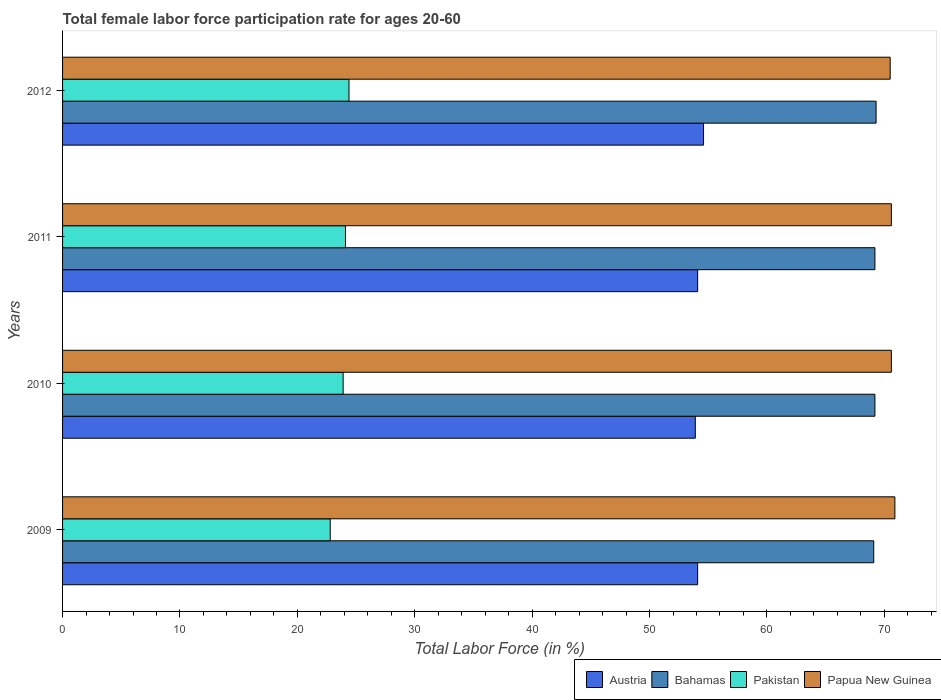How many different coloured bars are there?
Make the answer very short. 4. Are the number of bars on each tick of the Y-axis equal?
Keep it short and to the point. Yes. How many bars are there on the 4th tick from the top?
Make the answer very short. 4. In how many cases, is the number of bars for a given year not equal to the number of legend labels?
Keep it short and to the point. 0. What is the female labor force participation rate in Papua New Guinea in 2011?
Offer a terse response. 70.6. Across all years, what is the maximum female labor force participation rate in Austria?
Provide a short and direct response. 54.6. Across all years, what is the minimum female labor force participation rate in Austria?
Keep it short and to the point. 53.9. In which year was the female labor force participation rate in Austria minimum?
Your answer should be compact. 2010. What is the total female labor force participation rate in Austria in the graph?
Your response must be concise. 216.7. What is the difference between the female labor force participation rate in Austria in 2010 and that in 2012?
Offer a very short reply. -0.7. What is the difference between the female labor force participation rate in Bahamas in 2009 and the female labor force participation rate in Austria in 2011?
Make the answer very short. 15. What is the average female labor force participation rate in Pakistan per year?
Make the answer very short. 23.8. In the year 2009, what is the difference between the female labor force participation rate in Pakistan and female labor force participation rate in Bahamas?
Your answer should be compact. -46.3. What is the ratio of the female labor force participation rate in Papua New Guinea in 2009 to that in 2011?
Offer a terse response. 1. Is the female labor force participation rate in Bahamas in 2011 less than that in 2012?
Your response must be concise. Yes. What is the difference between the highest and the second highest female labor force participation rate in Papua New Guinea?
Make the answer very short. 0.3. What is the difference between the highest and the lowest female labor force participation rate in Papua New Guinea?
Your response must be concise. 0.4. In how many years, is the female labor force participation rate in Papua New Guinea greater than the average female labor force participation rate in Papua New Guinea taken over all years?
Provide a short and direct response. 1. Is the sum of the female labor force participation rate in Austria in 2009 and 2010 greater than the maximum female labor force participation rate in Pakistan across all years?
Provide a short and direct response. Yes. What does the 4th bar from the top in 2012 represents?
Your response must be concise. Austria. How many bars are there?
Your answer should be compact. 16. How many years are there in the graph?
Provide a short and direct response. 4. What is the difference between two consecutive major ticks on the X-axis?
Your answer should be compact. 10. Are the values on the major ticks of X-axis written in scientific E-notation?
Your answer should be compact. No. Where does the legend appear in the graph?
Offer a very short reply. Bottom right. What is the title of the graph?
Your answer should be compact. Total female labor force participation rate for ages 20-60. Does "Gambia, The" appear as one of the legend labels in the graph?
Offer a terse response. No. What is the Total Labor Force (in %) in Austria in 2009?
Your answer should be very brief. 54.1. What is the Total Labor Force (in %) in Bahamas in 2009?
Your answer should be very brief. 69.1. What is the Total Labor Force (in %) of Pakistan in 2009?
Give a very brief answer. 22.8. What is the Total Labor Force (in %) in Papua New Guinea in 2009?
Make the answer very short. 70.9. What is the Total Labor Force (in %) in Austria in 2010?
Offer a very short reply. 53.9. What is the Total Labor Force (in %) of Bahamas in 2010?
Offer a very short reply. 69.2. What is the Total Labor Force (in %) in Pakistan in 2010?
Your response must be concise. 23.9. What is the Total Labor Force (in %) in Papua New Guinea in 2010?
Make the answer very short. 70.6. What is the Total Labor Force (in %) of Austria in 2011?
Your answer should be compact. 54.1. What is the Total Labor Force (in %) in Bahamas in 2011?
Your answer should be very brief. 69.2. What is the Total Labor Force (in %) in Pakistan in 2011?
Provide a short and direct response. 24.1. What is the Total Labor Force (in %) of Papua New Guinea in 2011?
Keep it short and to the point. 70.6. What is the Total Labor Force (in %) of Austria in 2012?
Ensure brevity in your answer.  54.6. What is the Total Labor Force (in %) of Bahamas in 2012?
Your response must be concise. 69.3. What is the Total Labor Force (in %) of Pakistan in 2012?
Provide a short and direct response. 24.4. What is the Total Labor Force (in %) of Papua New Guinea in 2012?
Provide a short and direct response. 70.5. Across all years, what is the maximum Total Labor Force (in %) in Austria?
Ensure brevity in your answer.  54.6. Across all years, what is the maximum Total Labor Force (in %) in Bahamas?
Keep it short and to the point. 69.3. Across all years, what is the maximum Total Labor Force (in %) of Pakistan?
Your response must be concise. 24.4. Across all years, what is the maximum Total Labor Force (in %) in Papua New Guinea?
Make the answer very short. 70.9. Across all years, what is the minimum Total Labor Force (in %) of Austria?
Make the answer very short. 53.9. Across all years, what is the minimum Total Labor Force (in %) in Bahamas?
Provide a succinct answer. 69.1. Across all years, what is the minimum Total Labor Force (in %) in Pakistan?
Ensure brevity in your answer.  22.8. Across all years, what is the minimum Total Labor Force (in %) of Papua New Guinea?
Your answer should be very brief. 70.5. What is the total Total Labor Force (in %) of Austria in the graph?
Offer a terse response. 216.7. What is the total Total Labor Force (in %) of Bahamas in the graph?
Offer a terse response. 276.8. What is the total Total Labor Force (in %) of Pakistan in the graph?
Ensure brevity in your answer.  95.2. What is the total Total Labor Force (in %) in Papua New Guinea in the graph?
Your response must be concise. 282.6. What is the difference between the Total Labor Force (in %) in Papua New Guinea in 2009 and that in 2010?
Provide a succinct answer. 0.3. What is the difference between the Total Labor Force (in %) of Austria in 2009 and that in 2011?
Offer a terse response. 0. What is the difference between the Total Labor Force (in %) of Pakistan in 2009 and that in 2011?
Make the answer very short. -1.3. What is the difference between the Total Labor Force (in %) of Papua New Guinea in 2009 and that in 2011?
Keep it short and to the point. 0.3. What is the difference between the Total Labor Force (in %) of Papua New Guinea in 2009 and that in 2012?
Ensure brevity in your answer.  0.4. What is the difference between the Total Labor Force (in %) of Austria in 2010 and that in 2011?
Provide a succinct answer. -0.2. What is the difference between the Total Labor Force (in %) of Bahamas in 2010 and that in 2011?
Give a very brief answer. 0. What is the difference between the Total Labor Force (in %) of Austria in 2010 and that in 2012?
Provide a short and direct response. -0.7. What is the difference between the Total Labor Force (in %) of Bahamas in 2010 and that in 2012?
Your response must be concise. -0.1. What is the difference between the Total Labor Force (in %) of Austria in 2011 and that in 2012?
Your response must be concise. -0.5. What is the difference between the Total Labor Force (in %) of Bahamas in 2011 and that in 2012?
Your answer should be very brief. -0.1. What is the difference between the Total Labor Force (in %) of Pakistan in 2011 and that in 2012?
Provide a short and direct response. -0.3. What is the difference between the Total Labor Force (in %) of Papua New Guinea in 2011 and that in 2012?
Your answer should be compact. 0.1. What is the difference between the Total Labor Force (in %) of Austria in 2009 and the Total Labor Force (in %) of Bahamas in 2010?
Keep it short and to the point. -15.1. What is the difference between the Total Labor Force (in %) of Austria in 2009 and the Total Labor Force (in %) of Pakistan in 2010?
Make the answer very short. 30.2. What is the difference between the Total Labor Force (in %) of Austria in 2009 and the Total Labor Force (in %) of Papua New Guinea in 2010?
Your response must be concise. -16.5. What is the difference between the Total Labor Force (in %) in Bahamas in 2009 and the Total Labor Force (in %) in Pakistan in 2010?
Give a very brief answer. 45.2. What is the difference between the Total Labor Force (in %) in Bahamas in 2009 and the Total Labor Force (in %) in Papua New Guinea in 2010?
Provide a short and direct response. -1.5. What is the difference between the Total Labor Force (in %) of Pakistan in 2009 and the Total Labor Force (in %) of Papua New Guinea in 2010?
Your answer should be compact. -47.8. What is the difference between the Total Labor Force (in %) in Austria in 2009 and the Total Labor Force (in %) in Bahamas in 2011?
Provide a short and direct response. -15.1. What is the difference between the Total Labor Force (in %) of Austria in 2009 and the Total Labor Force (in %) of Papua New Guinea in 2011?
Provide a short and direct response. -16.5. What is the difference between the Total Labor Force (in %) in Bahamas in 2009 and the Total Labor Force (in %) in Papua New Guinea in 2011?
Give a very brief answer. -1.5. What is the difference between the Total Labor Force (in %) in Pakistan in 2009 and the Total Labor Force (in %) in Papua New Guinea in 2011?
Your answer should be very brief. -47.8. What is the difference between the Total Labor Force (in %) of Austria in 2009 and the Total Labor Force (in %) of Bahamas in 2012?
Your answer should be very brief. -15.2. What is the difference between the Total Labor Force (in %) of Austria in 2009 and the Total Labor Force (in %) of Pakistan in 2012?
Make the answer very short. 29.7. What is the difference between the Total Labor Force (in %) in Austria in 2009 and the Total Labor Force (in %) in Papua New Guinea in 2012?
Provide a succinct answer. -16.4. What is the difference between the Total Labor Force (in %) in Bahamas in 2009 and the Total Labor Force (in %) in Pakistan in 2012?
Give a very brief answer. 44.7. What is the difference between the Total Labor Force (in %) of Bahamas in 2009 and the Total Labor Force (in %) of Papua New Guinea in 2012?
Offer a very short reply. -1.4. What is the difference between the Total Labor Force (in %) in Pakistan in 2009 and the Total Labor Force (in %) in Papua New Guinea in 2012?
Ensure brevity in your answer.  -47.7. What is the difference between the Total Labor Force (in %) of Austria in 2010 and the Total Labor Force (in %) of Bahamas in 2011?
Provide a short and direct response. -15.3. What is the difference between the Total Labor Force (in %) in Austria in 2010 and the Total Labor Force (in %) in Pakistan in 2011?
Make the answer very short. 29.8. What is the difference between the Total Labor Force (in %) of Austria in 2010 and the Total Labor Force (in %) of Papua New Guinea in 2011?
Provide a succinct answer. -16.7. What is the difference between the Total Labor Force (in %) of Bahamas in 2010 and the Total Labor Force (in %) of Pakistan in 2011?
Your answer should be very brief. 45.1. What is the difference between the Total Labor Force (in %) of Bahamas in 2010 and the Total Labor Force (in %) of Papua New Guinea in 2011?
Your answer should be compact. -1.4. What is the difference between the Total Labor Force (in %) of Pakistan in 2010 and the Total Labor Force (in %) of Papua New Guinea in 2011?
Make the answer very short. -46.7. What is the difference between the Total Labor Force (in %) of Austria in 2010 and the Total Labor Force (in %) of Bahamas in 2012?
Your response must be concise. -15.4. What is the difference between the Total Labor Force (in %) of Austria in 2010 and the Total Labor Force (in %) of Pakistan in 2012?
Ensure brevity in your answer.  29.5. What is the difference between the Total Labor Force (in %) in Austria in 2010 and the Total Labor Force (in %) in Papua New Guinea in 2012?
Give a very brief answer. -16.6. What is the difference between the Total Labor Force (in %) of Bahamas in 2010 and the Total Labor Force (in %) of Pakistan in 2012?
Your response must be concise. 44.8. What is the difference between the Total Labor Force (in %) in Pakistan in 2010 and the Total Labor Force (in %) in Papua New Guinea in 2012?
Offer a very short reply. -46.6. What is the difference between the Total Labor Force (in %) in Austria in 2011 and the Total Labor Force (in %) in Bahamas in 2012?
Ensure brevity in your answer.  -15.2. What is the difference between the Total Labor Force (in %) of Austria in 2011 and the Total Labor Force (in %) of Pakistan in 2012?
Give a very brief answer. 29.7. What is the difference between the Total Labor Force (in %) in Austria in 2011 and the Total Labor Force (in %) in Papua New Guinea in 2012?
Make the answer very short. -16.4. What is the difference between the Total Labor Force (in %) in Bahamas in 2011 and the Total Labor Force (in %) in Pakistan in 2012?
Ensure brevity in your answer.  44.8. What is the difference between the Total Labor Force (in %) of Pakistan in 2011 and the Total Labor Force (in %) of Papua New Guinea in 2012?
Provide a succinct answer. -46.4. What is the average Total Labor Force (in %) of Austria per year?
Your answer should be compact. 54.17. What is the average Total Labor Force (in %) of Bahamas per year?
Offer a very short reply. 69.2. What is the average Total Labor Force (in %) in Pakistan per year?
Your response must be concise. 23.8. What is the average Total Labor Force (in %) in Papua New Guinea per year?
Give a very brief answer. 70.65. In the year 2009, what is the difference between the Total Labor Force (in %) of Austria and Total Labor Force (in %) of Bahamas?
Offer a terse response. -15. In the year 2009, what is the difference between the Total Labor Force (in %) in Austria and Total Labor Force (in %) in Pakistan?
Your response must be concise. 31.3. In the year 2009, what is the difference between the Total Labor Force (in %) of Austria and Total Labor Force (in %) of Papua New Guinea?
Keep it short and to the point. -16.8. In the year 2009, what is the difference between the Total Labor Force (in %) in Bahamas and Total Labor Force (in %) in Pakistan?
Give a very brief answer. 46.3. In the year 2009, what is the difference between the Total Labor Force (in %) of Bahamas and Total Labor Force (in %) of Papua New Guinea?
Provide a succinct answer. -1.8. In the year 2009, what is the difference between the Total Labor Force (in %) of Pakistan and Total Labor Force (in %) of Papua New Guinea?
Keep it short and to the point. -48.1. In the year 2010, what is the difference between the Total Labor Force (in %) of Austria and Total Labor Force (in %) of Bahamas?
Give a very brief answer. -15.3. In the year 2010, what is the difference between the Total Labor Force (in %) in Austria and Total Labor Force (in %) in Pakistan?
Provide a short and direct response. 30. In the year 2010, what is the difference between the Total Labor Force (in %) in Austria and Total Labor Force (in %) in Papua New Guinea?
Provide a short and direct response. -16.7. In the year 2010, what is the difference between the Total Labor Force (in %) of Bahamas and Total Labor Force (in %) of Pakistan?
Offer a terse response. 45.3. In the year 2010, what is the difference between the Total Labor Force (in %) in Bahamas and Total Labor Force (in %) in Papua New Guinea?
Keep it short and to the point. -1.4. In the year 2010, what is the difference between the Total Labor Force (in %) in Pakistan and Total Labor Force (in %) in Papua New Guinea?
Ensure brevity in your answer.  -46.7. In the year 2011, what is the difference between the Total Labor Force (in %) of Austria and Total Labor Force (in %) of Bahamas?
Your answer should be compact. -15.1. In the year 2011, what is the difference between the Total Labor Force (in %) of Austria and Total Labor Force (in %) of Pakistan?
Provide a short and direct response. 30. In the year 2011, what is the difference between the Total Labor Force (in %) of Austria and Total Labor Force (in %) of Papua New Guinea?
Make the answer very short. -16.5. In the year 2011, what is the difference between the Total Labor Force (in %) of Bahamas and Total Labor Force (in %) of Pakistan?
Ensure brevity in your answer.  45.1. In the year 2011, what is the difference between the Total Labor Force (in %) of Pakistan and Total Labor Force (in %) of Papua New Guinea?
Give a very brief answer. -46.5. In the year 2012, what is the difference between the Total Labor Force (in %) in Austria and Total Labor Force (in %) in Bahamas?
Offer a very short reply. -14.7. In the year 2012, what is the difference between the Total Labor Force (in %) of Austria and Total Labor Force (in %) of Pakistan?
Offer a terse response. 30.2. In the year 2012, what is the difference between the Total Labor Force (in %) in Austria and Total Labor Force (in %) in Papua New Guinea?
Your response must be concise. -15.9. In the year 2012, what is the difference between the Total Labor Force (in %) in Bahamas and Total Labor Force (in %) in Pakistan?
Provide a succinct answer. 44.9. In the year 2012, what is the difference between the Total Labor Force (in %) in Bahamas and Total Labor Force (in %) in Papua New Guinea?
Offer a terse response. -1.2. In the year 2012, what is the difference between the Total Labor Force (in %) in Pakistan and Total Labor Force (in %) in Papua New Guinea?
Offer a terse response. -46.1. What is the ratio of the Total Labor Force (in %) of Austria in 2009 to that in 2010?
Your answer should be very brief. 1. What is the ratio of the Total Labor Force (in %) of Bahamas in 2009 to that in 2010?
Ensure brevity in your answer.  1. What is the ratio of the Total Labor Force (in %) of Pakistan in 2009 to that in 2010?
Your answer should be very brief. 0.95. What is the ratio of the Total Labor Force (in %) of Papua New Guinea in 2009 to that in 2010?
Your answer should be compact. 1. What is the ratio of the Total Labor Force (in %) of Austria in 2009 to that in 2011?
Offer a terse response. 1. What is the ratio of the Total Labor Force (in %) in Pakistan in 2009 to that in 2011?
Ensure brevity in your answer.  0.95. What is the ratio of the Total Labor Force (in %) in Papua New Guinea in 2009 to that in 2011?
Offer a very short reply. 1. What is the ratio of the Total Labor Force (in %) of Pakistan in 2009 to that in 2012?
Give a very brief answer. 0.93. What is the ratio of the Total Labor Force (in %) of Austria in 2010 to that in 2011?
Provide a short and direct response. 1. What is the ratio of the Total Labor Force (in %) of Austria in 2010 to that in 2012?
Offer a terse response. 0.99. What is the ratio of the Total Labor Force (in %) in Bahamas in 2010 to that in 2012?
Ensure brevity in your answer.  1. What is the ratio of the Total Labor Force (in %) in Pakistan in 2010 to that in 2012?
Provide a short and direct response. 0.98. What is the ratio of the Total Labor Force (in %) in Papua New Guinea in 2010 to that in 2012?
Offer a terse response. 1. What is the ratio of the Total Labor Force (in %) in Bahamas in 2011 to that in 2012?
Provide a short and direct response. 1. What is the ratio of the Total Labor Force (in %) in Papua New Guinea in 2011 to that in 2012?
Give a very brief answer. 1. What is the difference between the highest and the second highest Total Labor Force (in %) of Austria?
Provide a succinct answer. 0.5. What is the difference between the highest and the second highest Total Labor Force (in %) in Bahamas?
Your answer should be very brief. 0.1. What is the difference between the highest and the second highest Total Labor Force (in %) in Pakistan?
Your response must be concise. 0.3. What is the difference between the highest and the lowest Total Labor Force (in %) of Austria?
Your answer should be compact. 0.7. What is the difference between the highest and the lowest Total Labor Force (in %) in Pakistan?
Give a very brief answer. 1.6. 